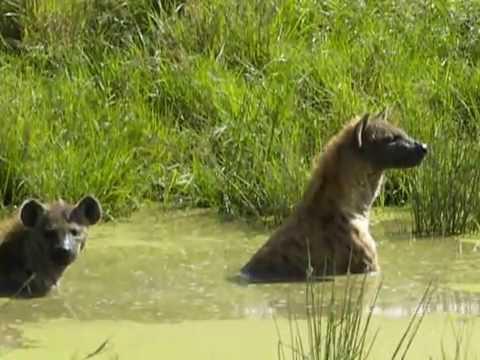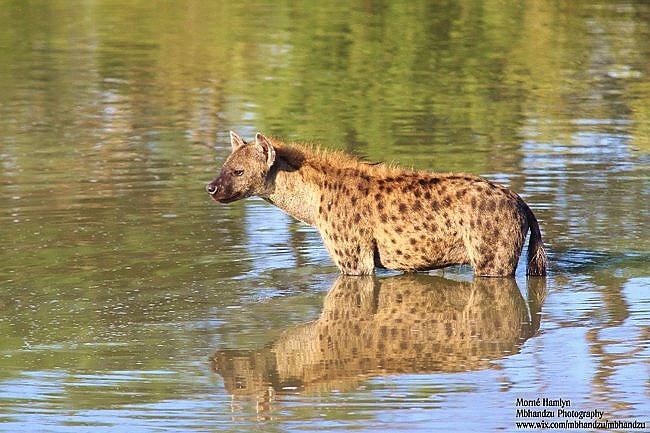The first image is the image on the left, the second image is the image on the right. For the images displayed, is the sentence "All hyenas are in the water, and one image shows a single hyena, with its head facing the camera." factually correct? Answer yes or no. No. The first image is the image on the left, the second image is the image on the right. Examine the images to the left and right. Is the description "The right image contains exactly one hyena wading through a body of water." accurate? Answer yes or no. Yes. 